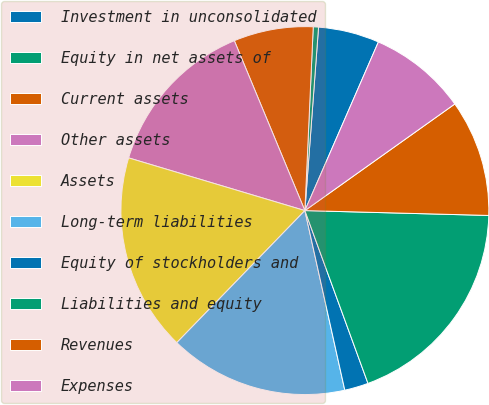Convert chart to OTSL. <chart><loc_0><loc_0><loc_500><loc_500><pie_chart><fcel>Investment in unconsolidated<fcel>Equity in net assets of<fcel>Current assets<fcel>Other assets<fcel>Assets<fcel>Long-term liabilities<fcel>Equity of stockholders and<fcel>Liabilities and equity<fcel>Revenues<fcel>Expenses<nl><fcel>5.36%<fcel>0.46%<fcel>6.99%<fcel>14.11%<fcel>17.37%<fcel>15.74%<fcel>2.09%<fcel>19.01%<fcel>10.26%<fcel>8.62%<nl></chart> 